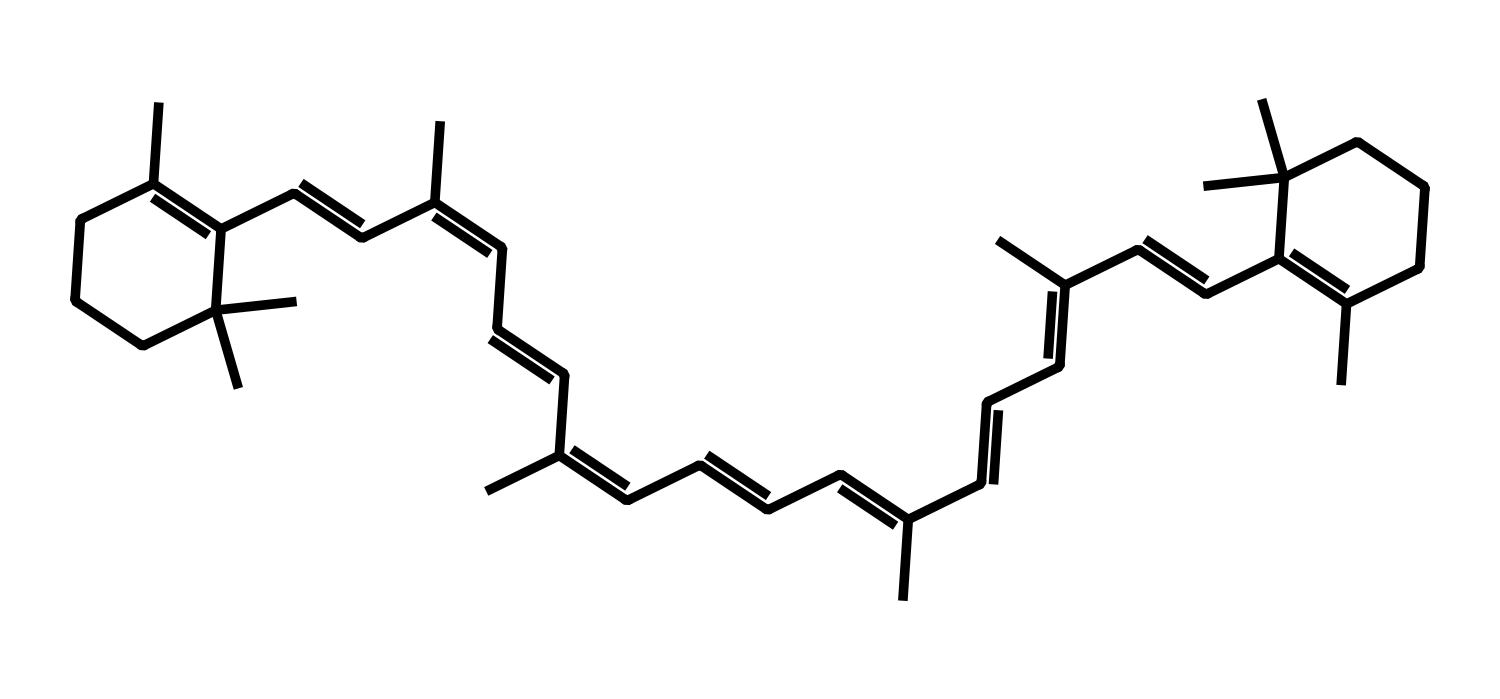what is the total number of carbon atoms in this molecule? To find the total number of carbon atoms in the SMILES representation, count the number of 'C' characters. Each 'C' denotes a carbon atom. After counting, we find there are 38 carbon atoms.
Answer: 38 how many double bonds are present in the structure? Double bonds in a chemical structure can often be inferred by looking for '=' signs in the SMILES format. Counting the '=' signs present reveals there are 8 double bonds in the chemical structure.
Answer: 8 which functional group is primarily represented in this dye? Analyzing the structure, since there are multiple carbon atoms connected with double bonds, this suggests the presence of an alkene functional group. In this case, due to extensive unsaturation, it emphasizes features of an alkene.
Answer: alkene is this dye likely to be water-soluble? A general rule for solubility is that compounds with fewer carbons or polar functional groups tend to be more soluble in water. Given the large number of carbon atoms and the predominance of non-polar characteristics in the structure, it suggests that this dye is likely not water-soluble.
Answer: no what type of dye is suggested by the presence of multiple carbon and double bonds? The presence of vibrantly colored structures primarily composed of carbon atoms with double bonds is typical of organic dyes, particularly indicating this is likely a type of synthetic organic dye, known for their vivid colors used in various applications.
Answer: synthetic organic dye what is the approximate molecular weight of this dye? To estimate the molecular weight, we assign typical atomic weights to each type of atom present in the structure based on the count from earlier questions. Considering there are 38 carbon atoms (each ~12 g/mol) and hydrogen atoms (around 1 g/mol), the approximate calculation for molecular weight comes out to be around 500 g/mol while being a rough estimate due to not accounting for exact hydrogen counts.
Answer: ~500 g/mol 